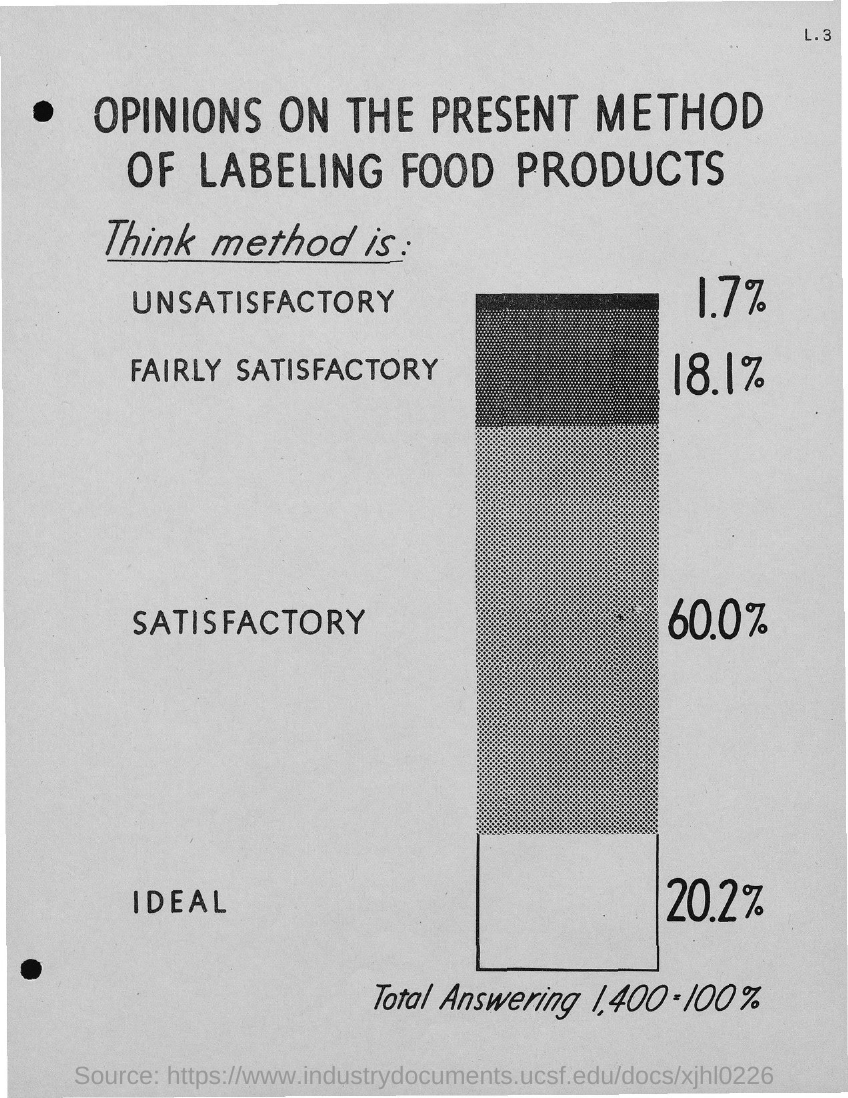Identify some key points in this picture. According to a recent survey, 20.2% of respondents believe that the current method of labeling food products is ideal. According to a recent survey, only 1.7% of the respondents expressed dissatisfaction with the current method of labeling food products. A recent survey found that only 18.1% of respondents expressed a satisfactory opinion on the present method of labeling food products. According to a recent survey, 60.0% of the opinions on the present method of labeling food products are satisfactory. 